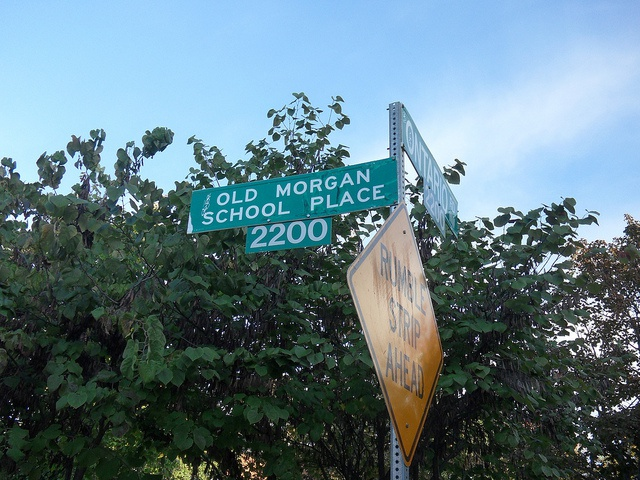Describe the objects in this image and their specific colors. I can see various objects in this image with different colors. 